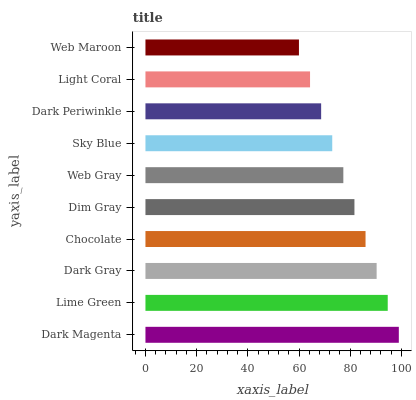Is Web Maroon the minimum?
Answer yes or no. Yes. Is Dark Magenta the maximum?
Answer yes or no. Yes. Is Lime Green the minimum?
Answer yes or no. No. Is Lime Green the maximum?
Answer yes or no. No. Is Dark Magenta greater than Lime Green?
Answer yes or no. Yes. Is Lime Green less than Dark Magenta?
Answer yes or no. Yes. Is Lime Green greater than Dark Magenta?
Answer yes or no. No. Is Dark Magenta less than Lime Green?
Answer yes or no. No. Is Dim Gray the high median?
Answer yes or no. Yes. Is Web Gray the low median?
Answer yes or no. Yes. Is Web Gray the high median?
Answer yes or no. No. Is Chocolate the low median?
Answer yes or no. No. 